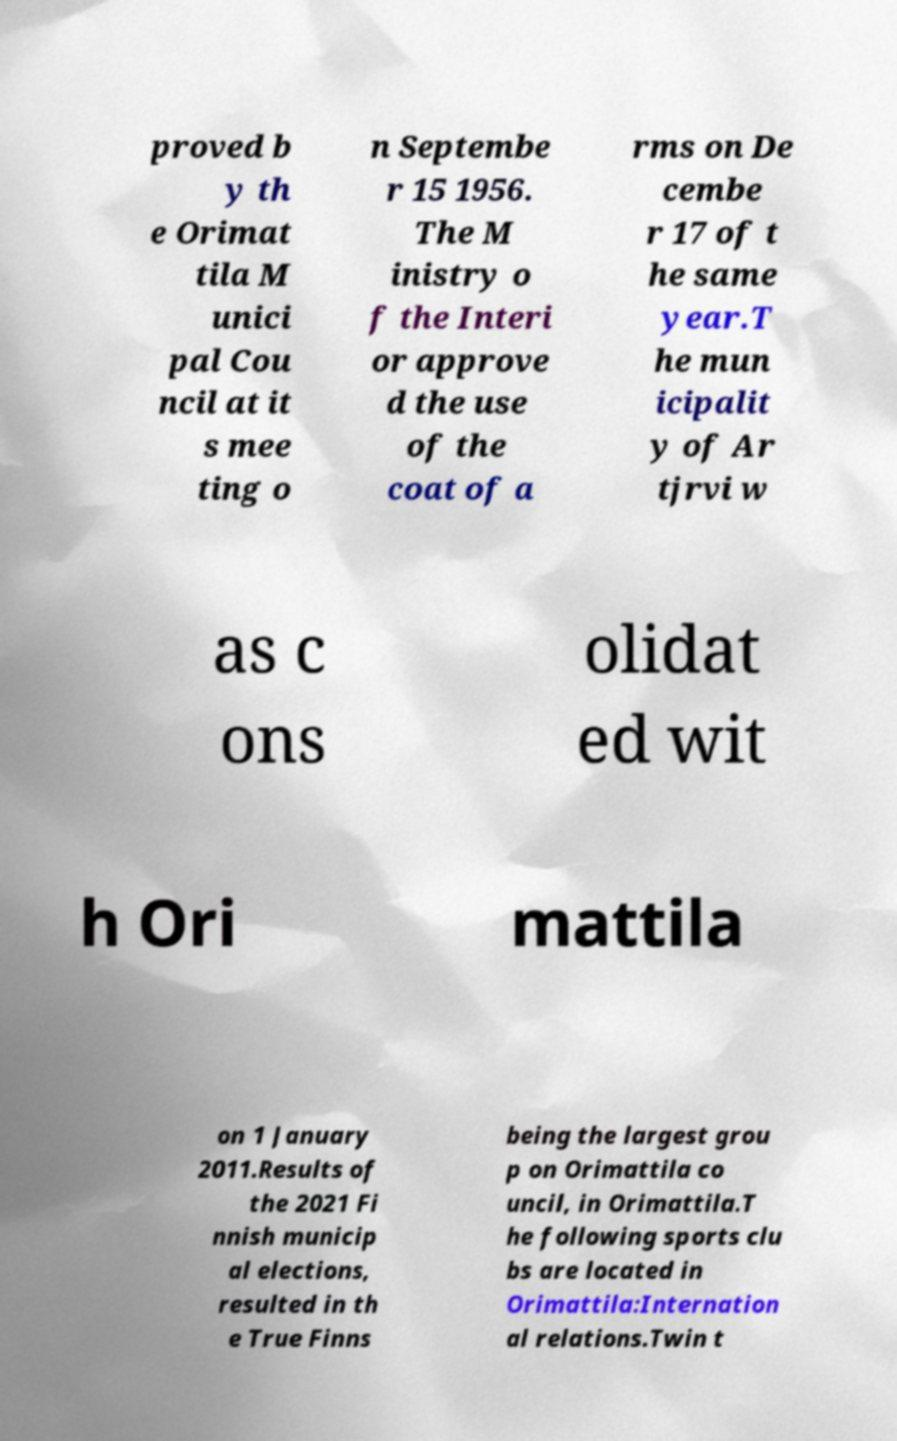What messages or text are displayed in this image? I need them in a readable, typed format. proved b y th e Orimat tila M unici pal Cou ncil at it s mee ting o n Septembe r 15 1956. The M inistry o f the Interi or approve d the use of the coat of a rms on De cembe r 17 of t he same year.T he mun icipalit y of Ar tjrvi w as c ons olidat ed wit h Ori mattila on 1 January 2011.Results of the 2021 Fi nnish municip al elections, resulted in th e True Finns being the largest grou p on Orimattila co uncil, in Orimattila.T he following sports clu bs are located in Orimattila:Internation al relations.Twin t 